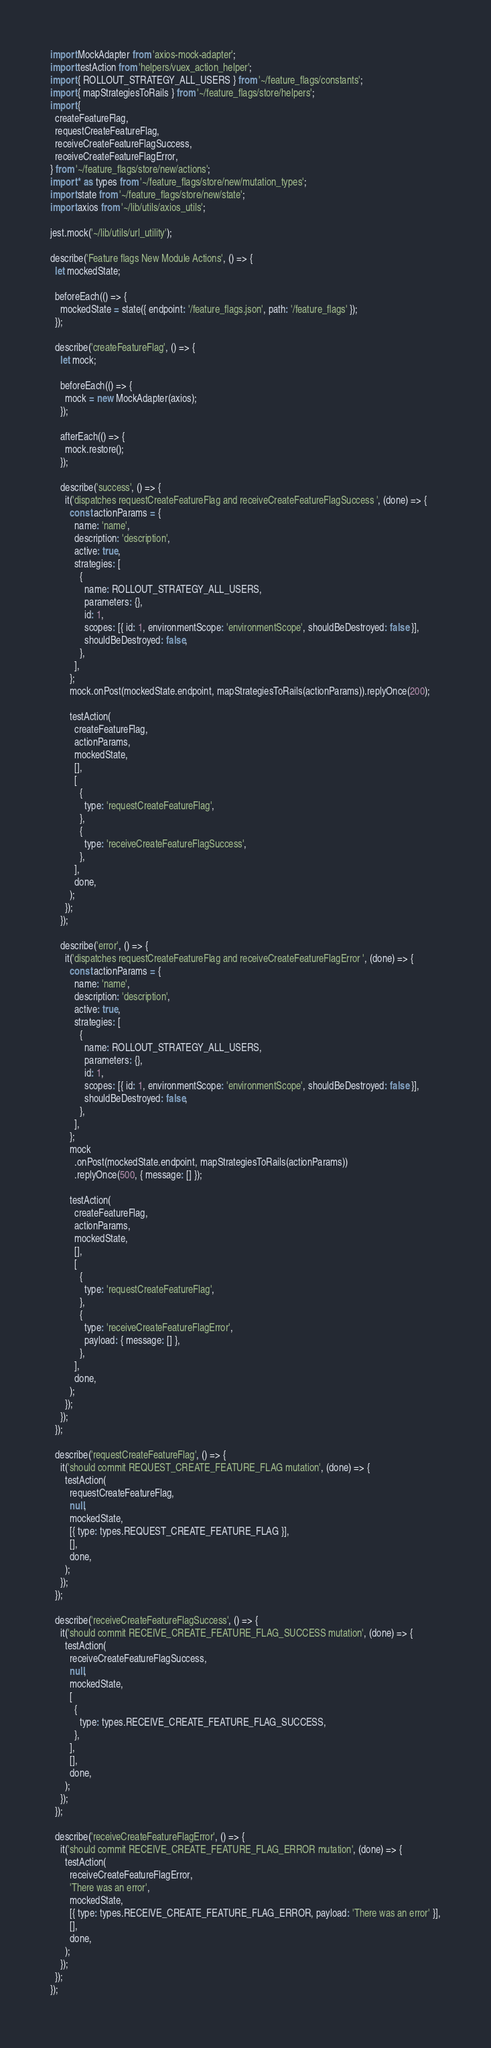<code> <loc_0><loc_0><loc_500><loc_500><_JavaScript_>import MockAdapter from 'axios-mock-adapter';
import testAction from 'helpers/vuex_action_helper';
import { ROLLOUT_STRATEGY_ALL_USERS } from '~/feature_flags/constants';
import { mapStrategiesToRails } from '~/feature_flags/store/helpers';
import {
  createFeatureFlag,
  requestCreateFeatureFlag,
  receiveCreateFeatureFlagSuccess,
  receiveCreateFeatureFlagError,
} from '~/feature_flags/store/new/actions';
import * as types from '~/feature_flags/store/new/mutation_types';
import state from '~/feature_flags/store/new/state';
import axios from '~/lib/utils/axios_utils';

jest.mock('~/lib/utils/url_utility');

describe('Feature flags New Module Actions', () => {
  let mockedState;

  beforeEach(() => {
    mockedState = state({ endpoint: '/feature_flags.json', path: '/feature_flags' });
  });

  describe('createFeatureFlag', () => {
    let mock;

    beforeEach(() => {
      mock = new MockAdapter(axios);
    });

    afterEach(() => {
      mock.restore();
    });

    describe('success', () => {
      it('dispatches requestCreateFeatureFlag and receiveCreateFeatureFlagSuccess ', (done) => {
        const actionParams = {
          name: 'name',
          description: 'description',
          active: true,
          strategies: [
            {
              name: ROLLOUT_STRATEGY_ALL_USERS,
              parameters: {},
              id: 1,
              scopes: [{ id: 1, environmentScope: 'environmentScope', shouldBeDestroyed: false }],
              shouldBeDestroyed: false,
            },
          ],
        };
        mock.onPost(mockedState.endpoint, mapStrategiesToRails(actionParams)).replyOnce(200);

        testAction(
          createFeatureFlag,
          actionParams,
          mockedState,
          [],
          [
            {
              type: 'requestCreateFeatureFlag',
            },
            {
              type: 'receiveCreateFeatureFlagSuccess',
            },
          ],
          done,
        );
      });
    });

    describe('error', () => {
      it('dispatches requestCreateFeatureFlag and receiveCreateFeatureFlagError ', (done) => {
        const actionParams = {
          name: 'name',
          description: 'description',
          active: true,
          strategies: [
            {
              name: ROLLOUT_STRATEGY_ALL_USERS,
              parameters: {},
              id: 1,
              scopes: [{ id: 1, environmentScope: 'environmentScope', shouldBeDestroyed: false }],
              shouldBeDestroyed: false,
            },
          ],
        };
        mock
          .onPost(mockedState.endpoint, mapStrategiesToRails(actionParams))
          .replyOnce(500, { message: [] });

        testAction(
          createFeatureFlag,
          actionParams,
          mockedState,
          [],
          [
            {
              type: 'requestCreateFeatureFlag',
            },
            {
              type: 'receiveCreateFeatureFlagError',
              payload: { message: [] },
            },
          ],
          done,
        );
      });
    });
  });

  describe('requestCreateFeatureFlag', () => {
    it('should commit REQUEST_CREATE_FEATURE_FLAG mutation', (done) => {
      testAction(
        requestCreateFeatureFlag,
        null,
        mockedState,
        [{ type: types.REQUEST_CREATE_FEATURE_FLAG }],
        [],
        done,
      );
    });
  });

  describe('receiveCreateFeatureFlagSuccess', () => {
    it('should commit RECEIVE_CREATE_FEATURE_FLAG_SUCCESS mutation', (done) => {
      testAction(
        receiveCreateFeatureFlagSuccess,
        null,
        mockedState,
        [
          {
            type: types.RECEIVE_CREATE_FEATURE_FLAG_SUCCESS,
          },
        ],
        [],
        done,
      );
    });
  });

  describe('receiveCreateFeatureFlagError', () => {
    it('should commit RECEIVE_CREATE_FEATURE_FLAG_ERROR mutation', (done) => {
      testAction(
        receiveCreateFeatureFlagError,
        'There was an error',
        mockedState,
        [{ type: types.RECEIVE_CREATE_FEATURE_FLAG_ERROR, payload: 'There was an error' }],
        [],
        done,
      );
    });
  });
});
</code> 